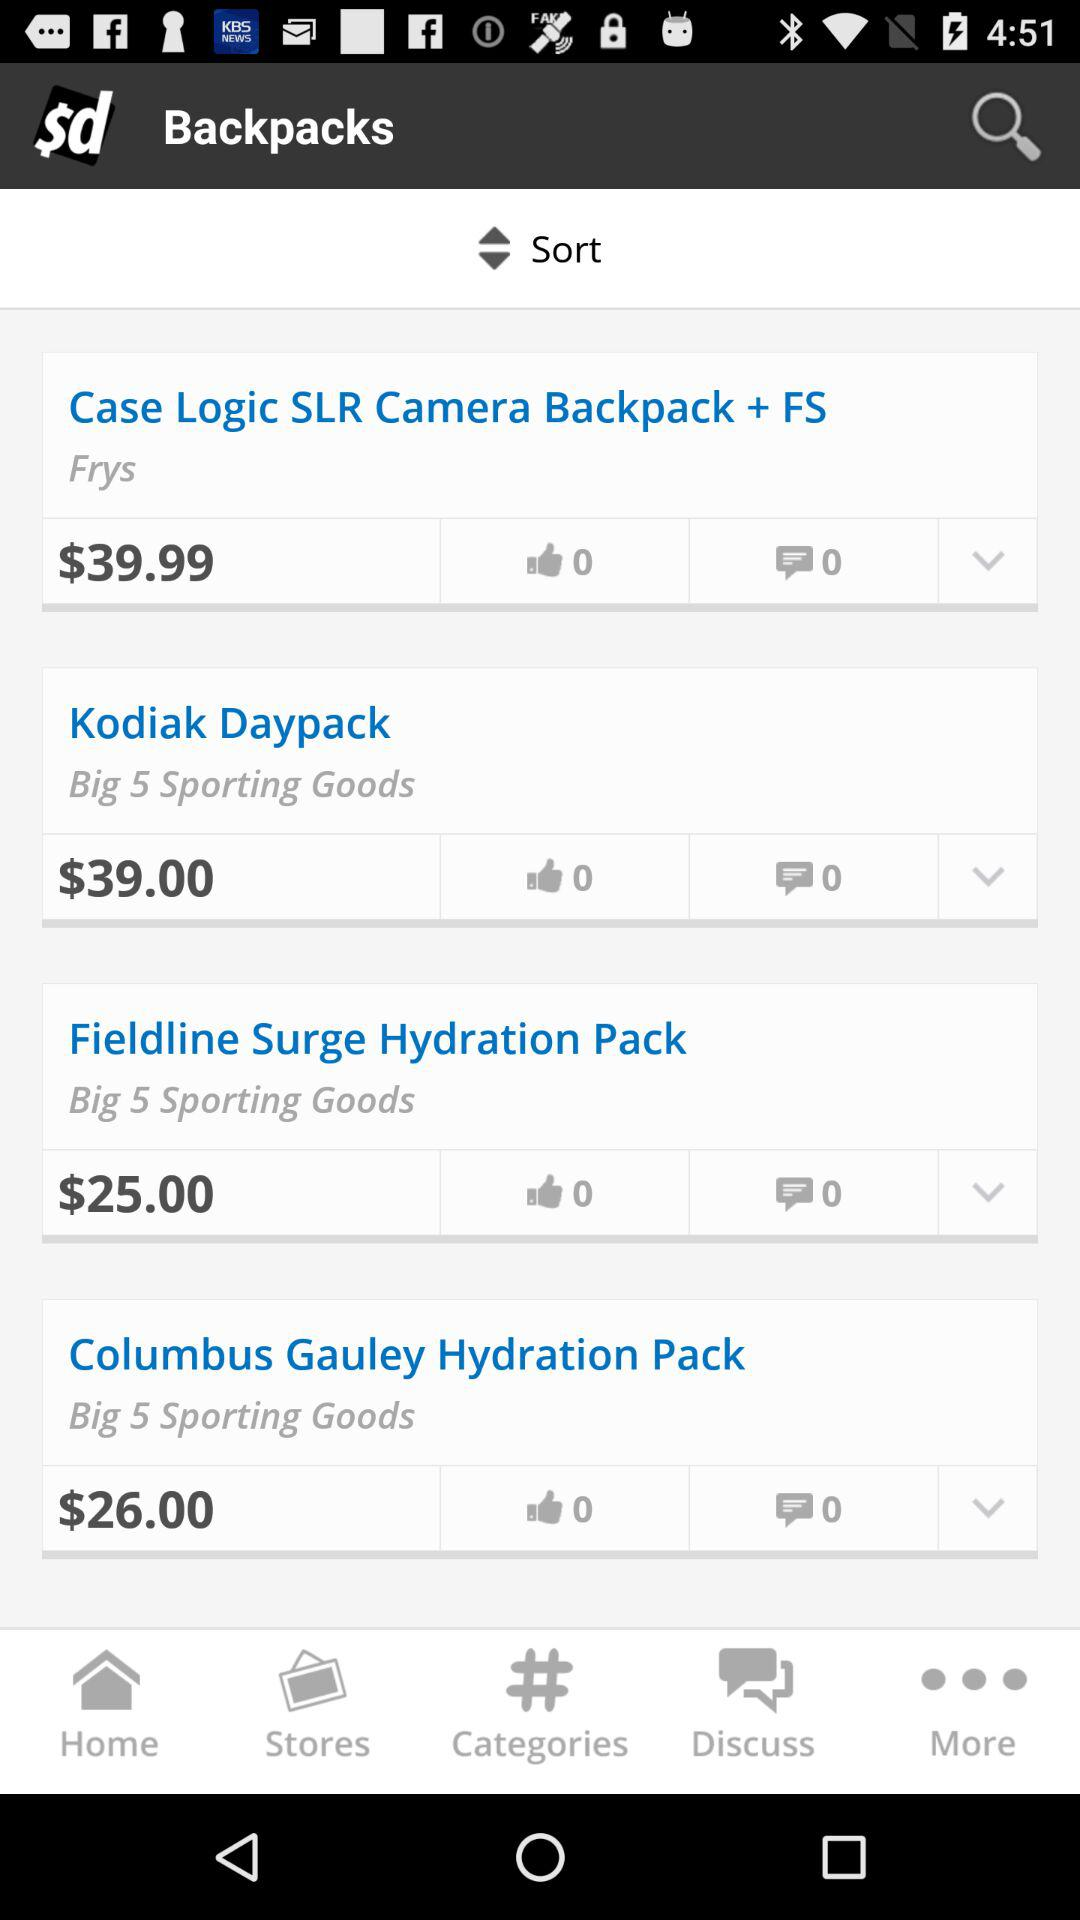Which item has a price of $26? The item that has a price of $26 is the "Columbus Gauley Hydration Pack". 